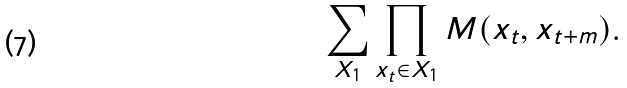Convert formula to latex. <formula><loc_0><loc_0><loc_500><loc_500>\sum _ { X _ { 1 } } \prod _ { x _ { t } \in X _ { 1 } } M ( x _ { t } , x _ { t + m } ) .</formula> 